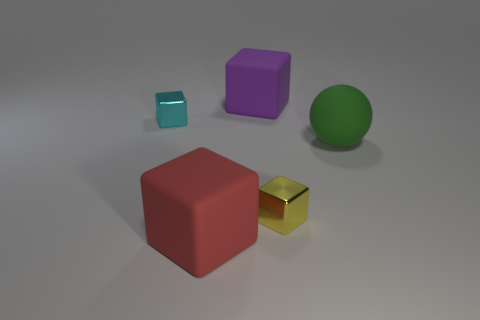How many big matte things are in front of the big cube that is in front of the cube that is to the left of the red rubber cube? There are no big matte objects situated in front of the large cube that precedes the cube located to the left of the red rubber cube. All objects are positioned independently without any overlapping alignment. 